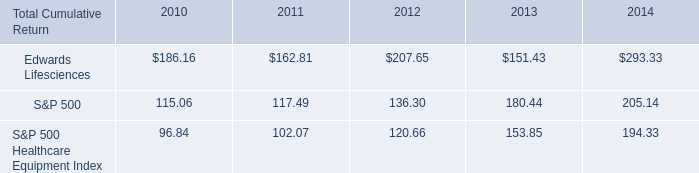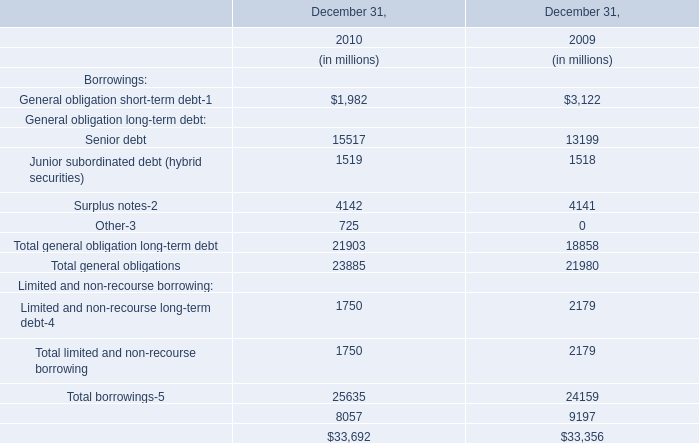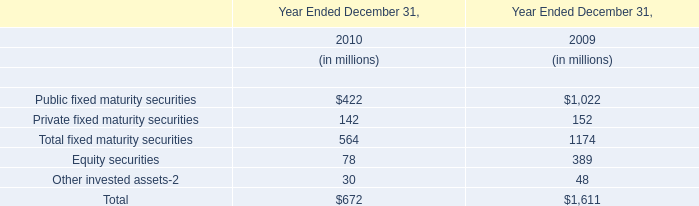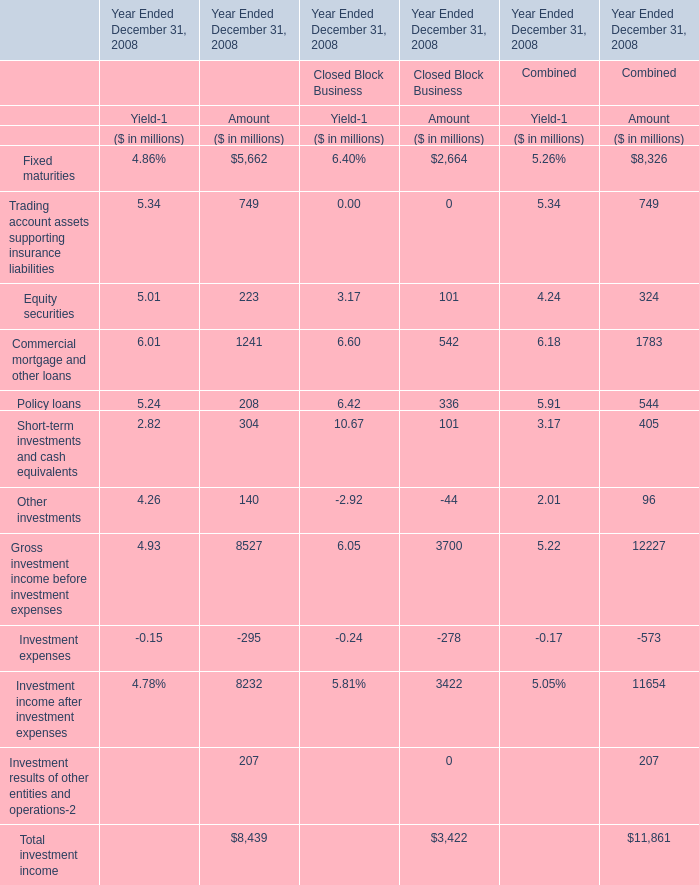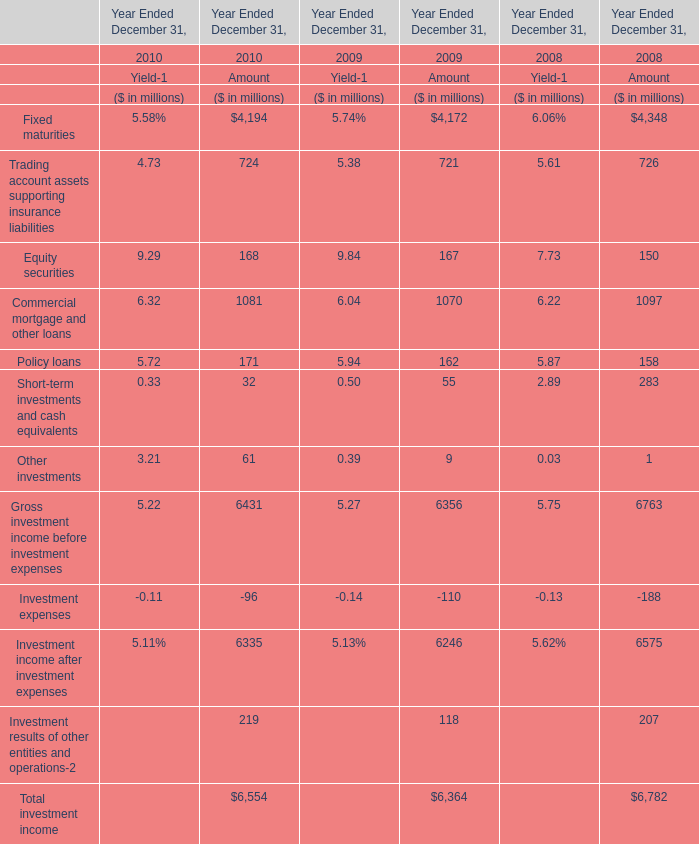What is the growing rate of Amount of Other investments in the year Ended December 31 with the highest Amount of Equity securities? 
Computations: ((61 - 9) / 9)
Answer: 5.77778. 